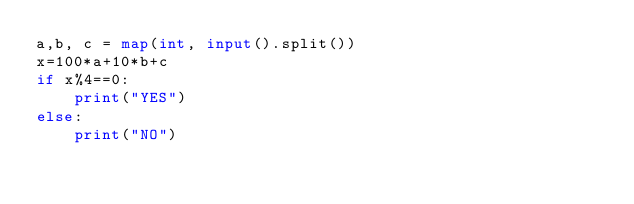Convert code to text. <code><loc_0><loc_0><loc_500><loc_500><_Python_>a,b, c = map(int, input().split())
x=100*a+10*b+c
if x%4==0:
    print("YES")
else:
    print("NO")</code> 